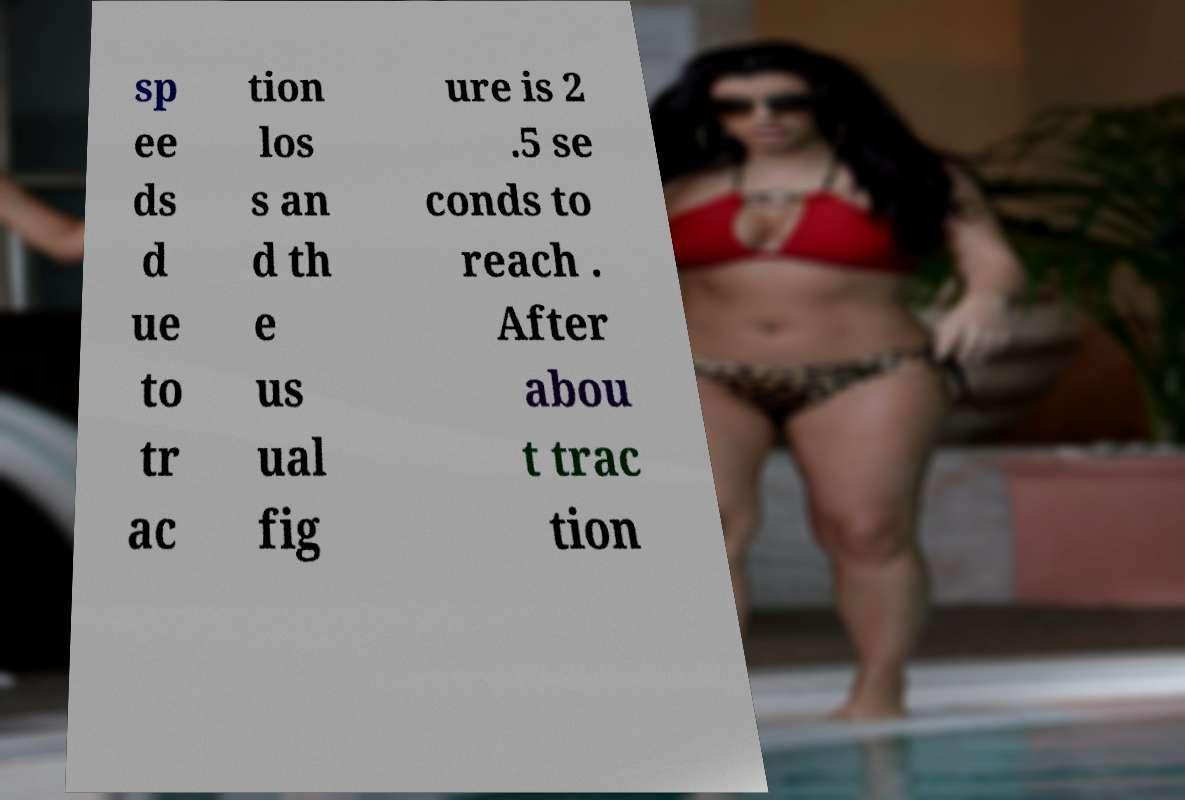What messages or text are displayed in this image? I need them in a readable, typed format. sp ee ds d ue to tr ac tion los s an d th e us ual fig ure is 2 .5 se conds to reach . After abou t trac tion 